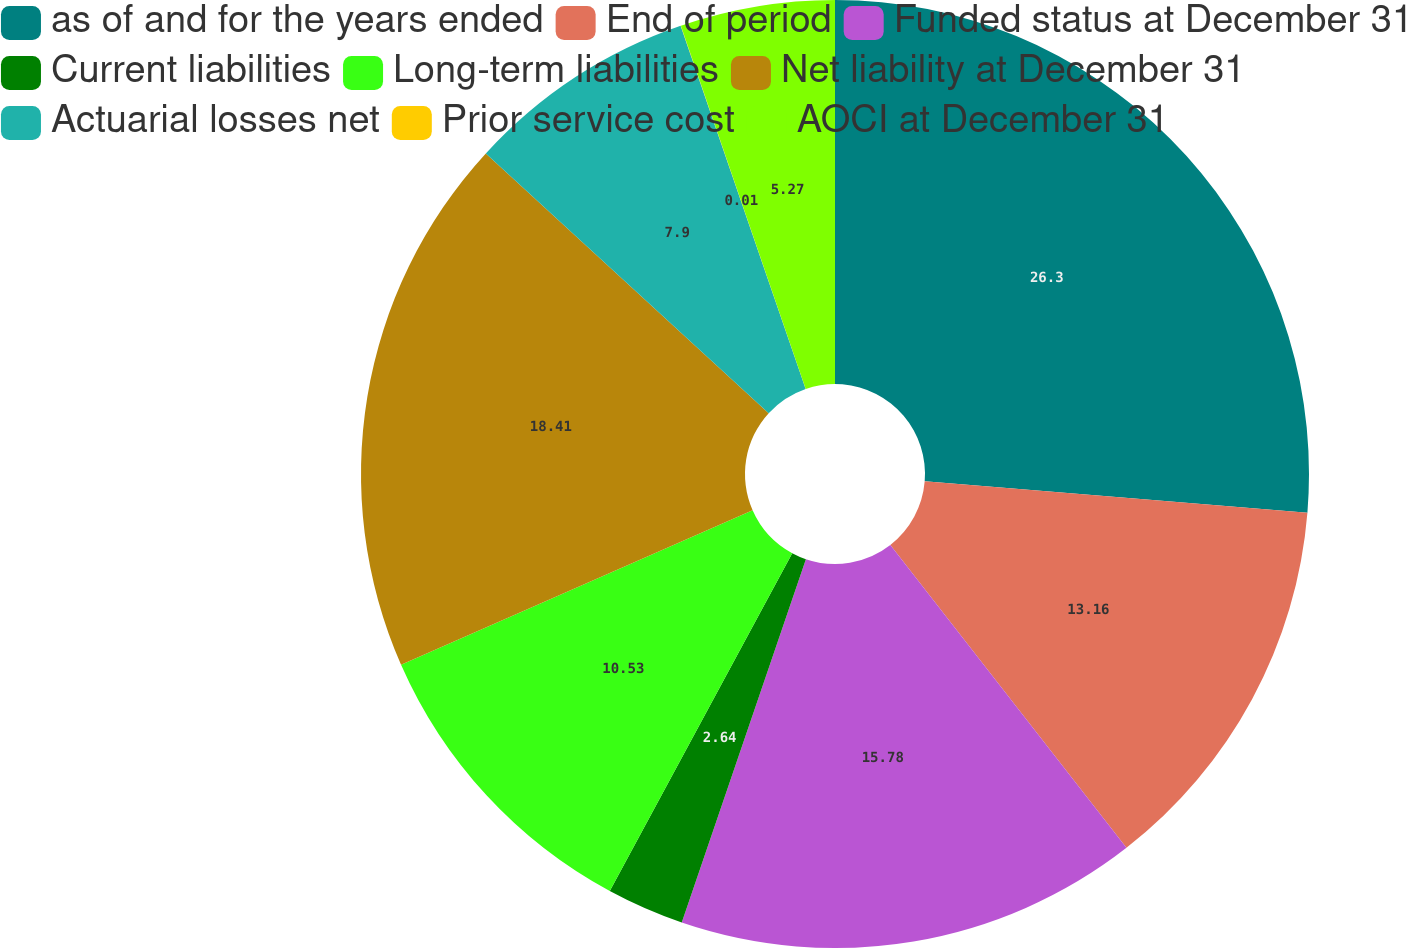<chart> <loc_0><loc_0><loc_500><loc_500><pie_chart><fcel>as of and for the years ended<fcel>End of period<fcel>Funded status at December 31<fcel>Current liabilities<fcel>Long-term liabilities<fcel>Net liability at December 31<fcel>Actuarial losses net<fcel>Prior service cost<fcel>AOCI at December 31<nl><fcel>26.3%<fcel>13.16%<fcel>15.78%<fcel>2.64%<fcel>10.53%<fcel>18.41%<fcel>7.9%<fcel>0.01%<fcel>5.27%<nl></chart> 